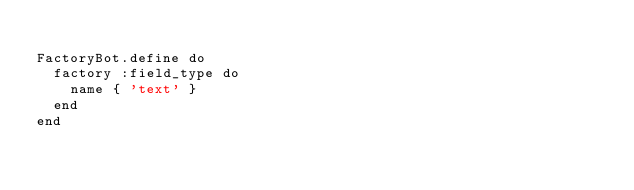Convert code to text. <code><loc_0><loc_0><loc_500><loc_500><_Ruby_>
FactoryBot.define do
  factory :field_type do
    name { 'text' }
  end
end
</code> 